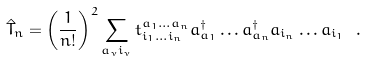<formula> <loc_0><loc_0><loc_500><loc_500>\hat { T } _ { n } = \left ( \frac { 1 } { n ! } \right ) ^ { 2 } \sum _ { a _ { \nu } i _ { \nu } } t _ { i _ { 1 } \dots i _ { n } } ^ { a _ { 1 } \dots a _ { n } } a ^ { \dagger } _ { a _ { 1 } } \dots a ^ { \dagger } _ { a _ { n } } a _ { i _ { n } } \dots a _ { i _ { 1 } } \ .</formula> 